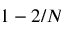Convert formula to latex. <formula><loc_0><loc_0><loc_500><loc_500>1 - 2 / N</formula> 